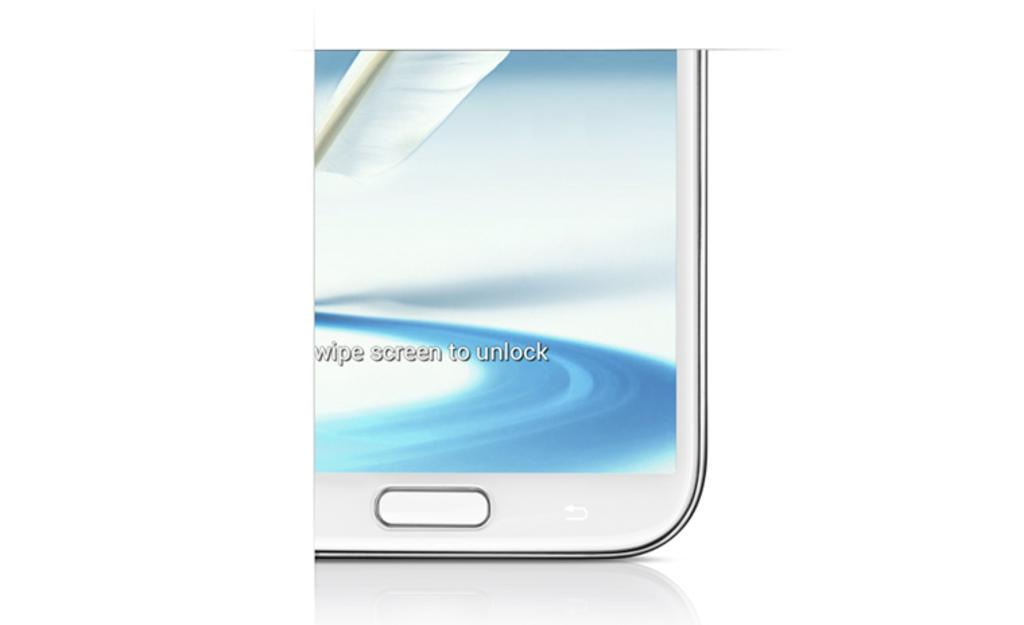Provide a one-sentence caption for the provided image. A picture of a partial phone shot with wipe screen to unlock displayed. 